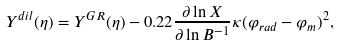Convert formula to latex. <formula><loc_0><loc_0><loc_500><loc_500>Y ^ { d i l } ( \eta ) = Y ^ { G R } ( \eta ) - 0 . 2 2 \frac { \partial \ln X } { \partial \ln B ^ { - 1 } } \kappa ( \varphi _ { r a d } - \varphi _ { m } ) ^ { 2 } ,</formula> 